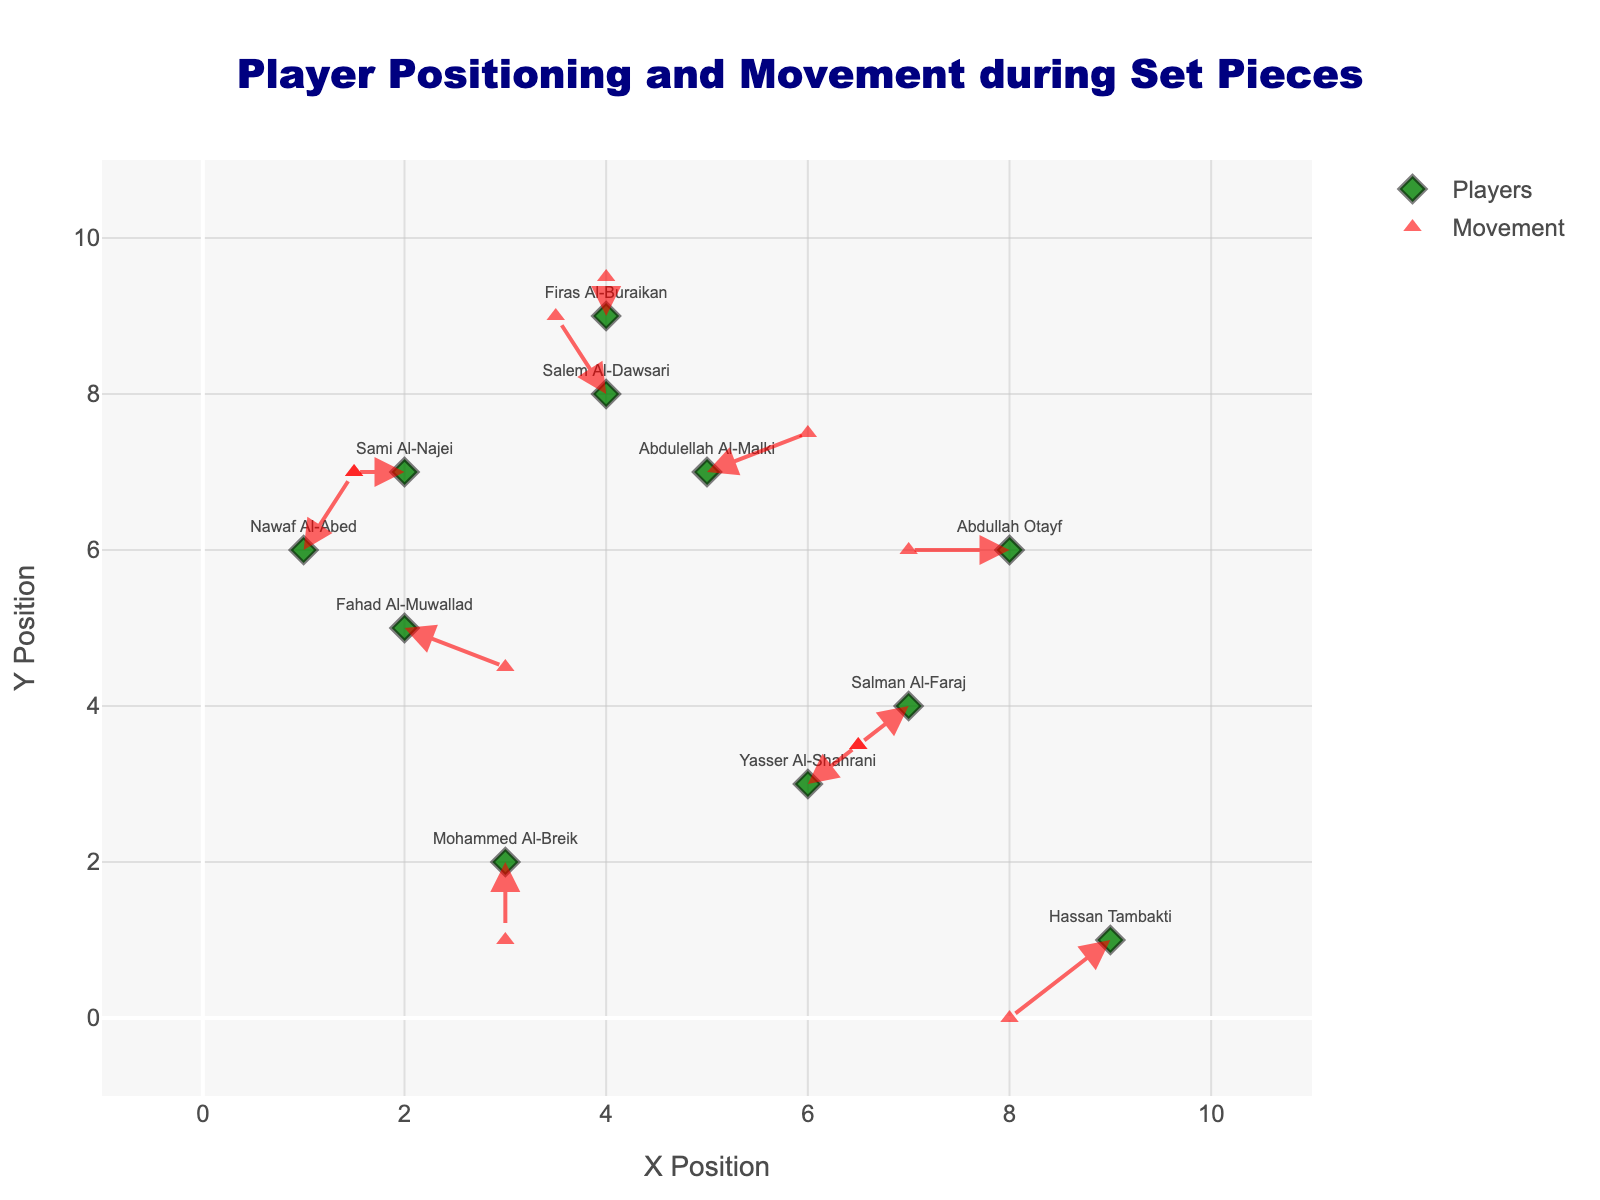Which player shows the highest movement in the x-axis? To determine this, observe the change in x position by comparing the initial and final x values. Fahad Al-Muwallad moves from x=2 to x=3 (a change of +1), which is the highest positive movement in the x direction.
Answer: Fahad Al-Muwallad Which player moves downward the most? Look at the arrows pointing downwards and compare their lengths. Mohammed Al-Breik has the most downward movement, from y=2 to y=1 (a change of -1).
Answer: Mohammed Al-Breik Which player has no movement? Identify the player whose arrow length is zero (no change in x or y). Firas Al-Buraikan remains at the same position with coordinates (4,9) and does not move.
Answer: Firas Al-Buraikan What is the average x-coordinate of all players initially? Add all initial x-coordinates and divide by the number of players. Sum = (2+4+6+8+3+5+7+1+9+4+2) = 51, Number of players = 11, so average = 51/11 ≈ 4.64
Answer: 4.64 Which player has the smallest overall movement (Euclidean distance)? Calculate the Euclidean distance for each player using the formula sqrt((u^2) + (v^2)). Abdullah Otayf's movement is sqrt((-1)^2 + 0^2) = 1, which is among the smallest.
Answer: Abdullah Otayf Which player shows an upward and leftward direction of movement? Look for players whose arrows point upwards (positive y direction) and leftwards (negative x direction). Nawaf Al-Abed moves in both directions, upwards from y=6 to y=7, and leftwards from x=1 to x=0.5.
Answer: Nawaf Al-Abed What is the total vertical movement distance made by all players combined? Sum up all the changes in y-coordinates (v values). Total = -0.5 + 1 + 0.5 + 0 + -1 + 0.5 + -0.5 + 1 + -1 + 0.5 + 0 = 0.5
Answer: 0.5 How many players moved towards the positive x-direction? Count arrows pointing rightwards. Players who moved positively along x are Fahad Al-Muwallad (1), Yasser Al-Shahrani (0.5), Abdulellah Al-Malki (1), and Nawaf Al-Abed (0.5). Total = 4
Answer: 4 